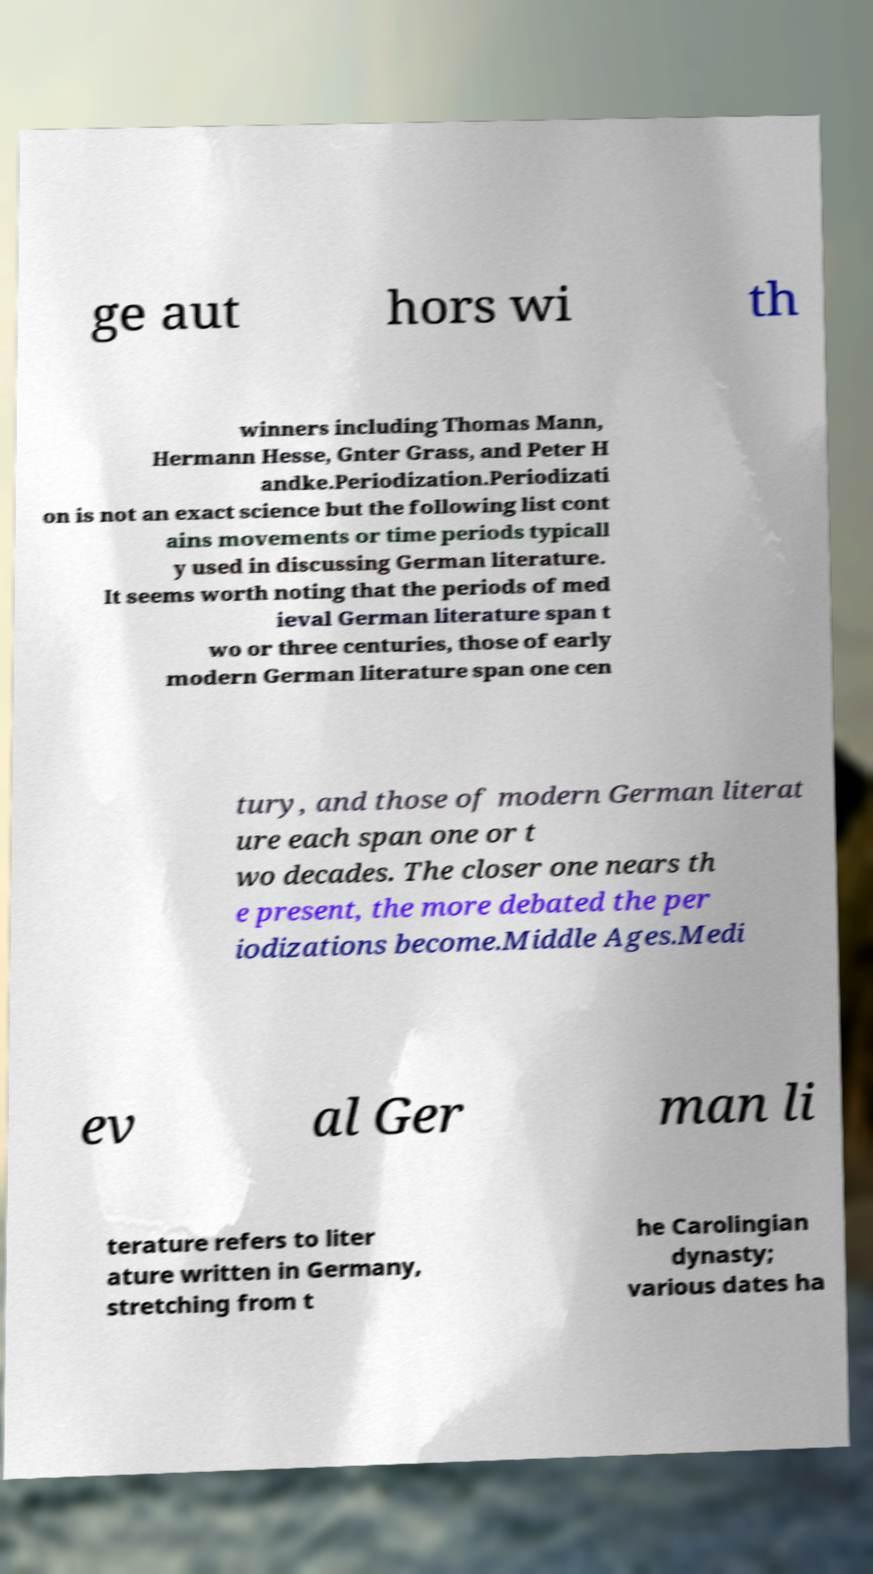Please read and relay the text visible in this image. What does it say? ge aut hors wi th winners including Thomas Mann, Hermann Hesse, Gnter Grass, and Peter H andke.Periodization.Periodizati on is not an exact science but the following list cont ains movements or time periods typicall y used in discussing German literature. It seems worth noting that the periods of med ieval German literature span t wo or three centuries, those of early modern German literature span one cen tury, and those of modern German literat ure each span one or t wo decades. The closer one nears th e present, the more debated the per iodizations become.Middle Ages.Medi ev al Ger man li terature refers to liter ature written in Germany, stretching from t he Carolingian dynasty; various dates ha 